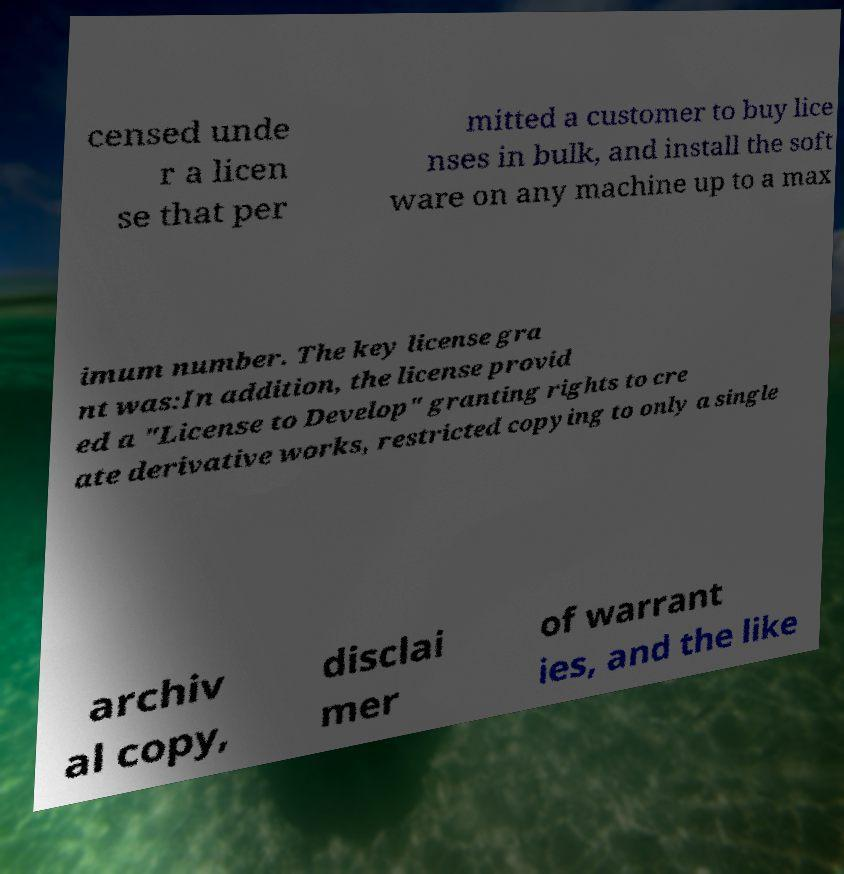Can you read and provide the text displayed in the image?This photo seems to have some interesting text. Can you extract and type it out for me? censed unde r a licen se that per mitted a customer to buy lice nses in bulk, and install the soft ware on any machine up to a max imum number. The key license gra nt was:In addition, the license provid ed a "License to Develop" granting rights to cre ate derivative works, restricted copying to only a single archiv al copy, disclai mer of warrant ies, and the like 